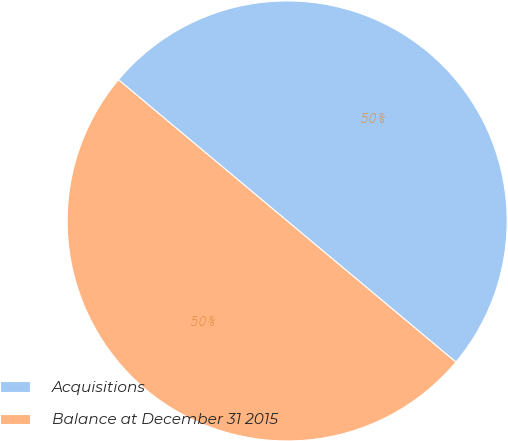Convert chart. <chart><loc_0><loc_0><loc_500><loc_500><pie_chart><fcel>Acquisitions<fcel>Balance at December 31 2015<nl><fcel>50.0%<fcel>50.0%<nl></chart> 